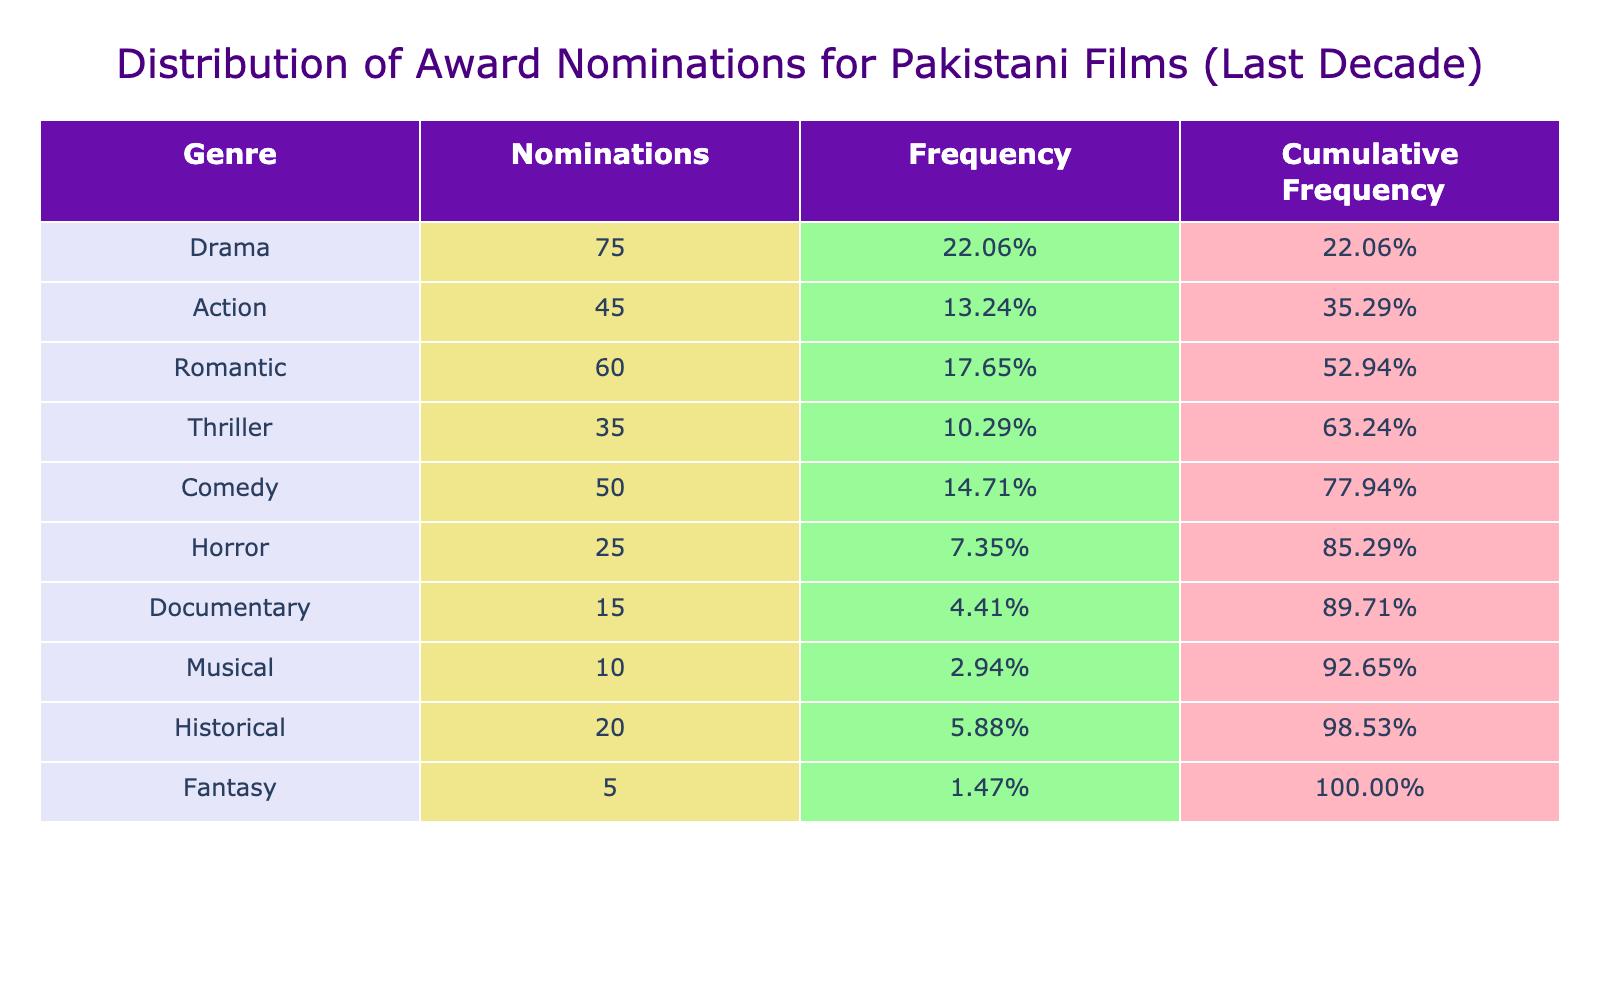What genre received the highest number of nominations? By looking at the 'Number_of_Nominations' column in the table, we see that 'Drama' has 75 nominations, which is the highest compared to other genres listed.
Answer: Drama What is the total number of nominations across all genres? To find the total, we sum the number of nominations for each genre: 75 + 45 + 60 + 35 + 50 + 25 + 15 + 10 + 20 + 5 = 395.
Answer: 395 What genre received fewer than 30 nominations? Referring to the 'Number_of_Nominations' column, we see 'Horror' with 25 and 'Musical' with 10, both less than 30.
Answer: Horror and Musical What is the frequency of Romantic genre nominations? The frequency is calculated as the number of nominations for the Romantic genre divided by the total nominations: 60 / 395 = 0.1519. This can also be represented as approximately 15.19%.
Answer: 15.19% Which genres have a cumulative frequency of over 70%? To find this, we calculate the cumulative frequency for each genre in order. The cumulative frequencies for 'Drama', 'Action', 'Romantic', and 'Thriller' combined exceed 70% (adding up to about 76.19%).
Answer: Drama, Action, Romantic, Thriller Is the number of nominations for Documentary films greater than that for Horror films? Looking at the table, 'Documentary' has 15 nominations while 'Horror' has 25. Since 15 is less than 25, the statement is false.
Answer: No What is the combined number of nominations for Comedy and Action genres? To find the combined nominations, we add the two values together: 50 (Comedy) + 45 (Action) = 95.
Answer: 95 If we were to rank the genres by their nominations, what would the second rank be? The ranking based on the number of nominations is: 1. Drama (75), 2. Romantic (60), 3. Action (45). Therefore, the second rank belongs to 'Romantic'.
Answer: Romantic Which genre has the lowest number of nominations? By examining the 'Number_of_Nominations', we see that 'Fantasy' has the lowest with only 5 nominations.
Answer: Fantasy 